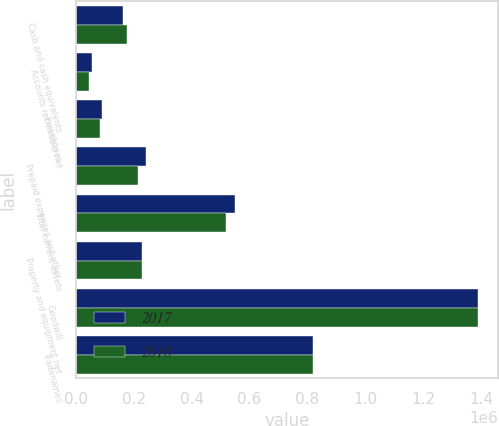<chart> <loc_0><loc_0><loc_500><loc_500><stacked_bar_chart><ecel><fcel>Cash and cash equivalents<fcel>Accounts receivable net<fcel>Inventories<fcel>Prepaid expenses and other<fcel>Total current assets<fcel>Property and equipment net<fcel>Goodwill<fcel>Tradenames<nl><fcel>2017<fcel>163851<fcel>55249<fcel>90202<fcel>241011<fcel>550313<fcel>228538<fcel>1.38893e+06<fcel>817525<nl><fcel>2018<fcel>176190<fcel>43961<fcel>82121<fcel>216065<fcel>518337<fcel>228538<fcel>1.38893e+06<fcel>817525<nl></chart> 